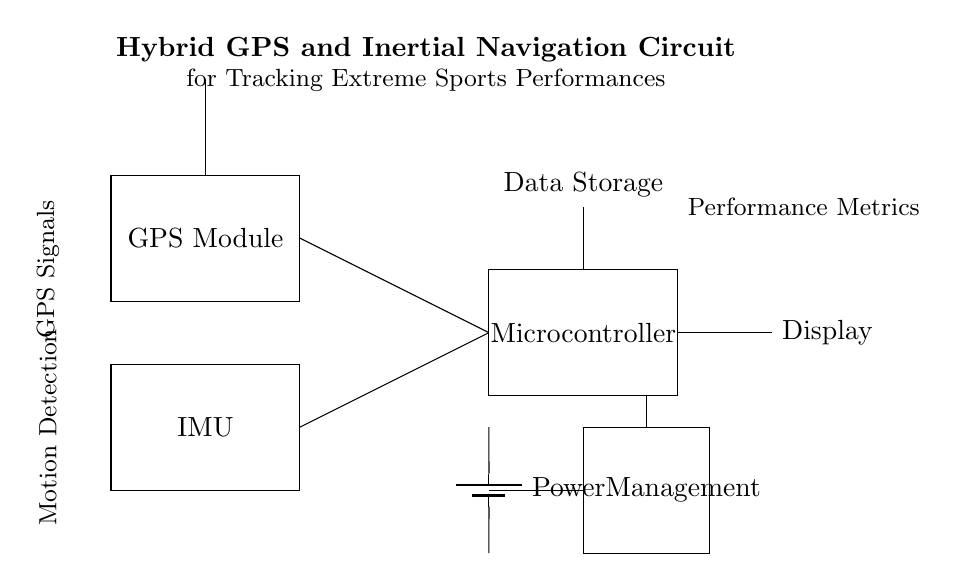What is the main purpose of the circuit? The circuit is designed for tracking extreme sports performances by combining GPS and inertial navigation data.
Answer: Tracking extreme sports performances Which component is responsible for GPS signals? The GPS Module in the diagram is specifically labeled as the component that processes GPS signals.
Answer: GPS Module How many connections are there to the microcontroller? There are two connections leading into the microcontroller from both the GPS Module and the IMU, totaling two inputs.
Answer: Two What type of battery is used in this circuit? The circuit uses a battery symbol, which typically represents a rechargeable battery suitable for powering electronic devices like this one.
Answer: Rechargeable battery What role does the power management component play? The Power Management system regulates power distribution to various components, ensuring that the circuit receives the correct voltage and current levels.
Answer: Regulates power distribution What is the function of the antenna in this circuit? The antenna is used to receive GPS signals from satellites, which aids in determining the location and navigation of the user.
Answer: Receives GPS signals Where is the data storage located in the circuit? Data storage is located above the microcontroller, indicated by a direct line connecting from the microcontroller, which suggests it holds processed information.
Answer: Above the microcontroller 